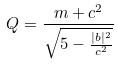Convert formula to latex. <formula><loc_0><loc_0><loc_500><loc_500>Q = \frac { m + c ^ { 2 } } { \sqrt { 5 - \frac { | b | ^ { 2 } } { c ^ { 2 } } } }</formula> 